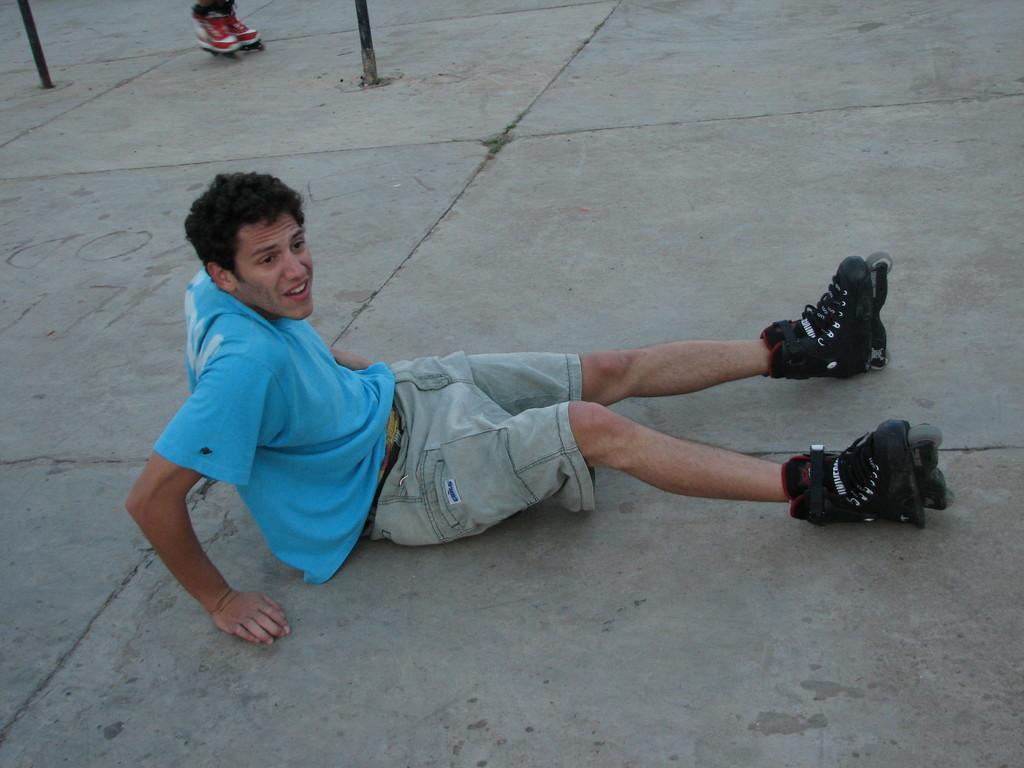In one or two sentences, can you explain what this image depicts? The man in the middle of the picture wearing a blue T-shirt is sitting on the floor. He is wearing the skate shoes. At the top, we see two poles and red color skate shoes. At the bottom, we see the pavement. 